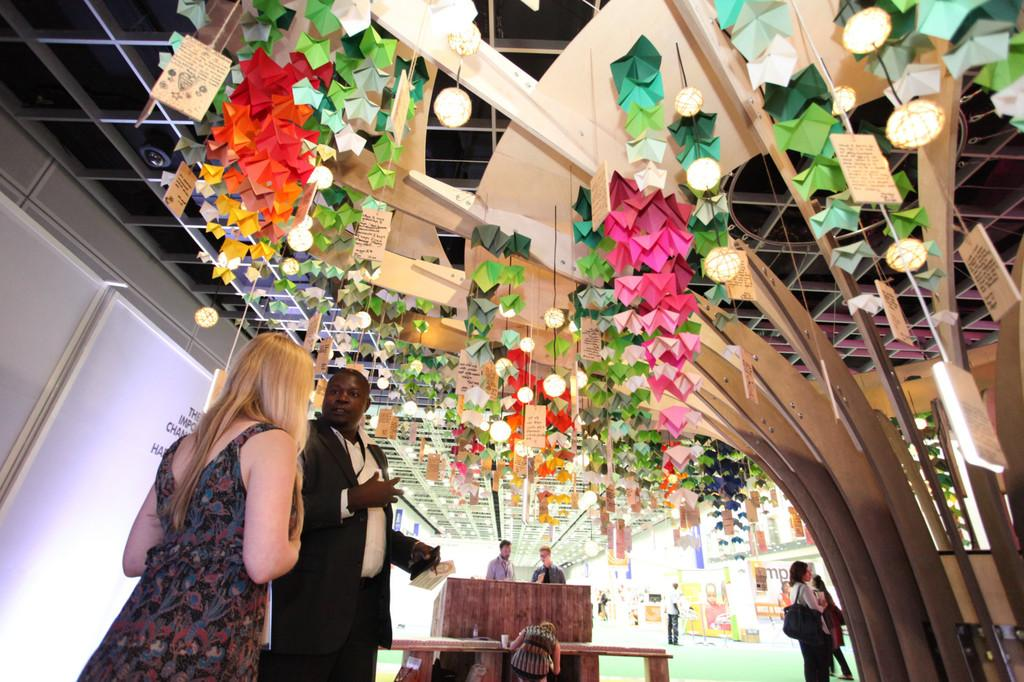How many people are in the image? There is a group of people in the image, but the exact number is not specified. What are the people in the image doing? The people are standing in the image. What can be seen in front of the group of people? There are lights and hoardings in front of the group of people. What type of sheep can be seen in the image? There are no sheep present in the image. What emotion is displayed by the people in the image? The image does not show any specific emotions of the people, so it cannot be determined from the image. 